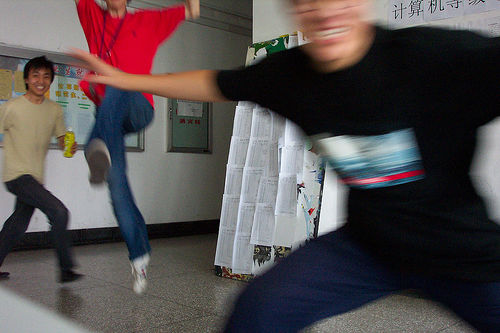What can you infer about the relationship between the people? The relaxed body language and expressions suggest they are comfortable with each other, likely indicating they are friends. The playful interaction and the smiles indicate a close and friendly relationship. What does the background tell us about where this photo was taken? The background, with its notice boards and flyers, resembles a hallway possibly in a school or a community building, which is often a social gathering place and a setting for informal, playful interactions like the one captured here. 